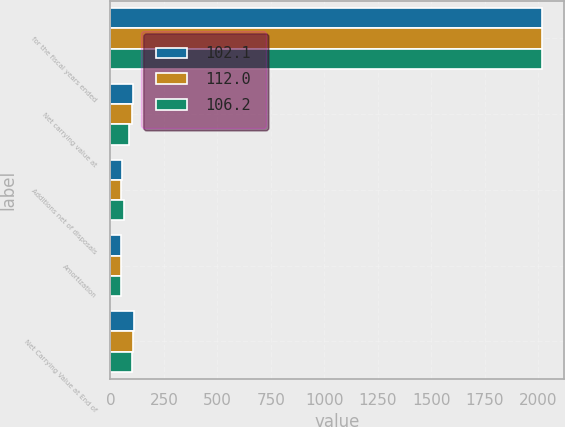Convert chart. <chart><loc_0><loc_0><loc_500><loc_500><stacked_bar_chart><ecel><fcel>for the fiscal years ended<fcel>Net carrying value at<fcel>Additions net of disposals<fcel>Amortization<fcel>Net Carrying Value at End of<nl><fcel>102.1<fcel>2019<fcel>106.2<fcel>53.8<fcel>48<fcel>112<nl><fcel>112<fcel>2018<fcel>102.1<fcel>51.2<fcel>47.1<fcel>106.2<nl><fcel>106.2<fcel>2017<fcel>88.1<fcel>63.1<fcel>49.1<fcel>102.1<nl></chart> 